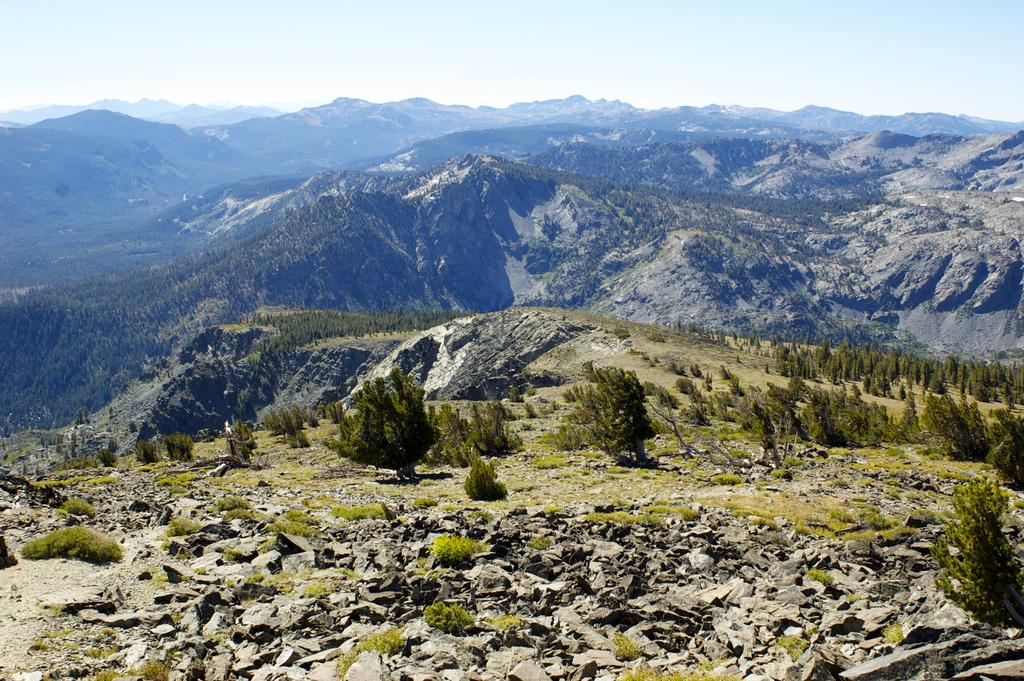What type of natural formation can be seen in the image? There are mountains in the image. What covers the mountains in the image? The mountains are covered with plants. Can you describe the vegetation on the mountains? There is grass visible on the mountains. What other elements can be seen in the image? There are rocks in the image. What part of the natural environment is visible in the image? The sky is visible in the image. How does the deer start its journey in the image? There are no deer present in the image, so it is not possible to answer that question. 